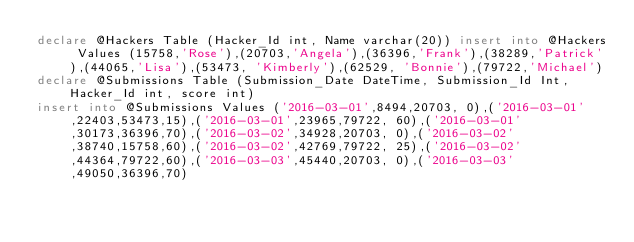Convert code to text. <code><loc_0><loc_0><loc_500><loc_500><_SQL_>declare @Hackers Table (Hacker_Id int, Name varchar(20)) insert into @Hackers Values (15758,'Rose'),(20703,'Angela'),(36396,'Frank'),(38289,'Patrick'),(44065,'Lisa'),(53473, 'Kimberly'),(62529, 'Bonnie'),(79722,'Michael')
declare @Submissions Table (Submission_Date DateTime, Submission_Id Int, Hacker_Id int, score int)
insert into @Submissions Values ('2016-03-01',8494,20703, 0),('2016-03-01',22403,53473,15),('2016-03-01',23965,79722, 60),('2016-03-01',30173,36396,70),('2016-03-02',34928,20703, 0),('2016-03-02',38740,15758,60),('2016-03-02',42769,79722, 25),('2016-03-02',44364,79722,60),('2016-03-03',45440,20703, 0),('2016-03-03',49050,36396,70)</code> 